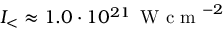Convert formula to latex. <formula><loc_0><loc_0><loc_500><loc_500>I _ { < } \approx 1 . 0 \cdot 1 0 ^ { 2 1 } \, W c m ^ { - 2 }</formula> 